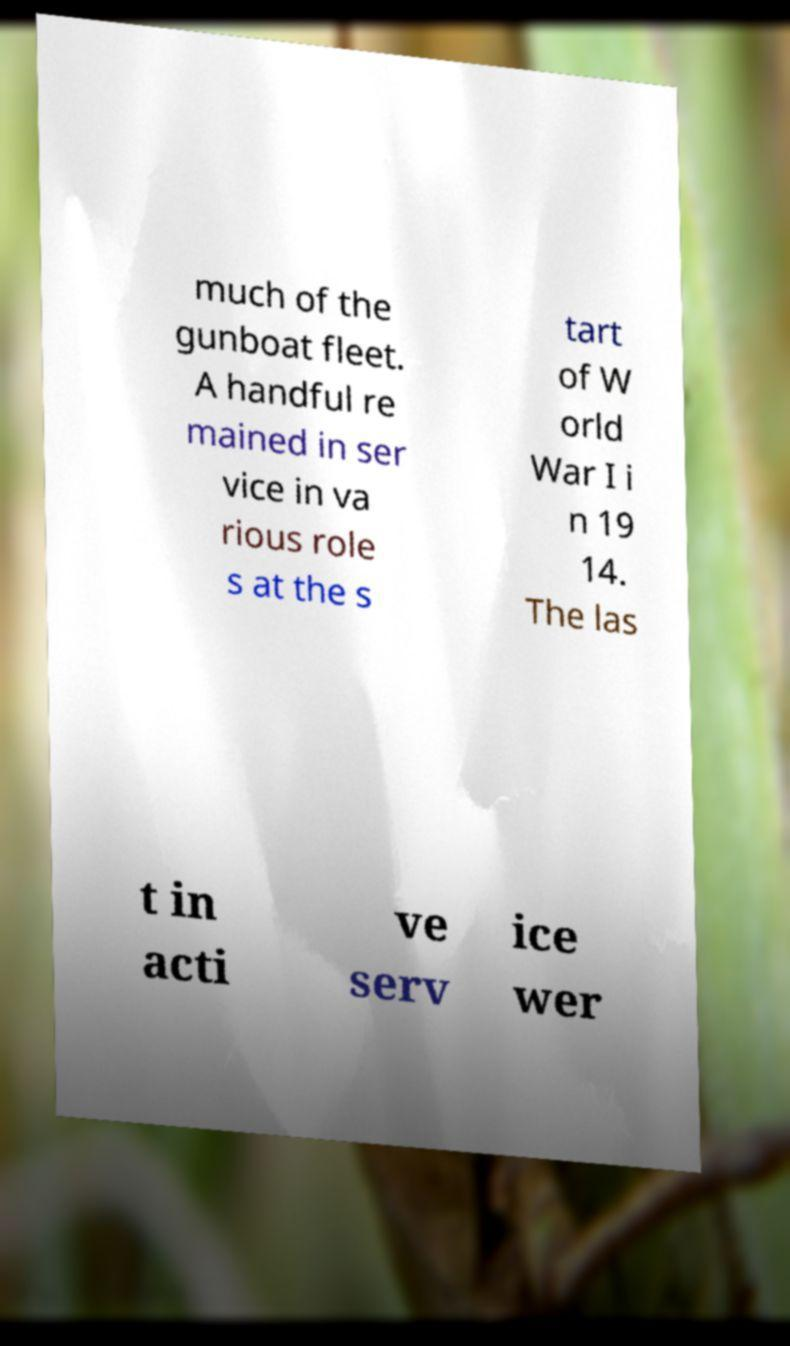Please identify and transcribe the text found in this image. much of the gunboat fleet. A handful re mained in ser vice in va rious role s at the s tart of W orld War I i n 19 14. The las t in acti ve serv ice wer 